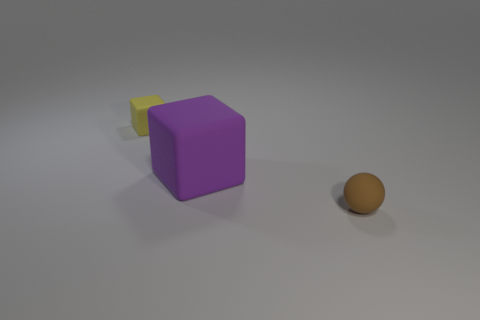Add 2 brown spheres. How many objects exist? 5 Subtract all blocks. How many objects are left? 1 Add 1 tiny yellow cubes. How many tiny yellow cubes exist? 2 Subtract 0 blue cylinders. How many objects are left? 3 Subtract all big things. Subtract all purple rubber objects. How many objects are left? 1 Add 1 cubes. How many cubes are left? 3 